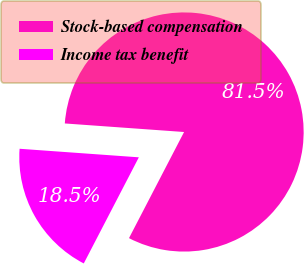Convert chart to OTSL. <chart><loc_0><loc_0><loc_500><loc_500><pie_chart><fcel>Stock-based compensation<fcel>Income tax benefit<nl><fcel>81.48%<fcel>18.52%<nl></chart> 